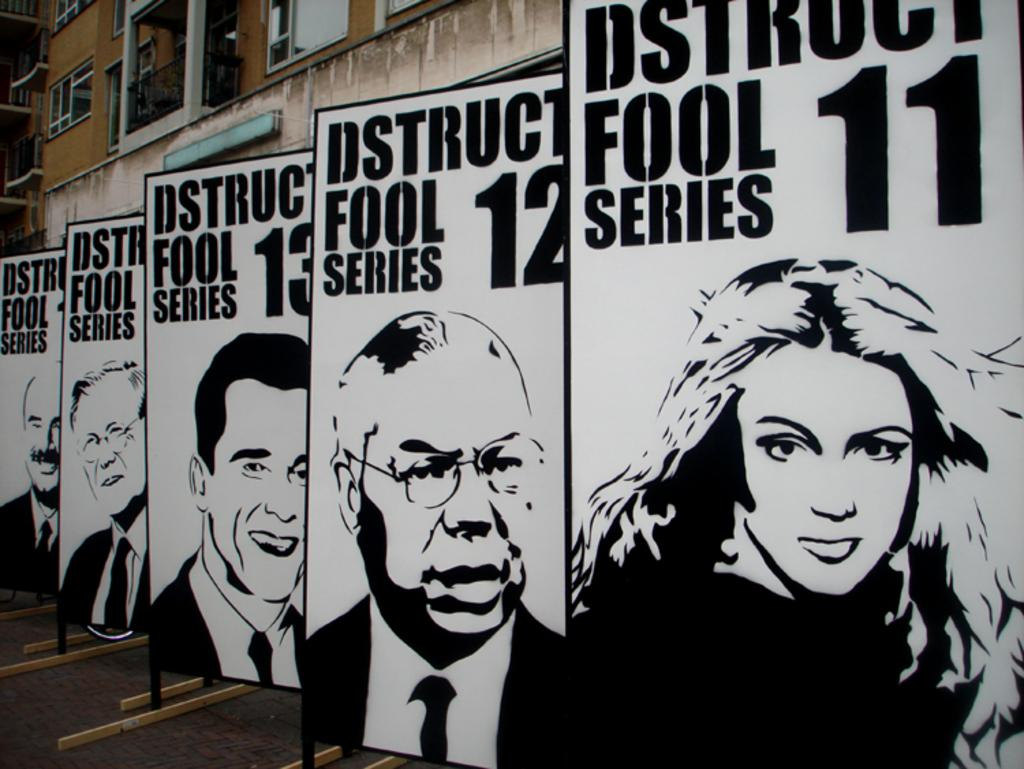What is displayed on the boards in the image? The boards have text and pictures of persons in the image. What can be seen in the background of the image? There is a building and windows visible in the background. What is at the bottom of the image? There is a road at the bottom of the image. What type of vest is being worn by the person in the image? There is no person visible in the image, so it is not possible to determine if anyone is wearing a vest. 